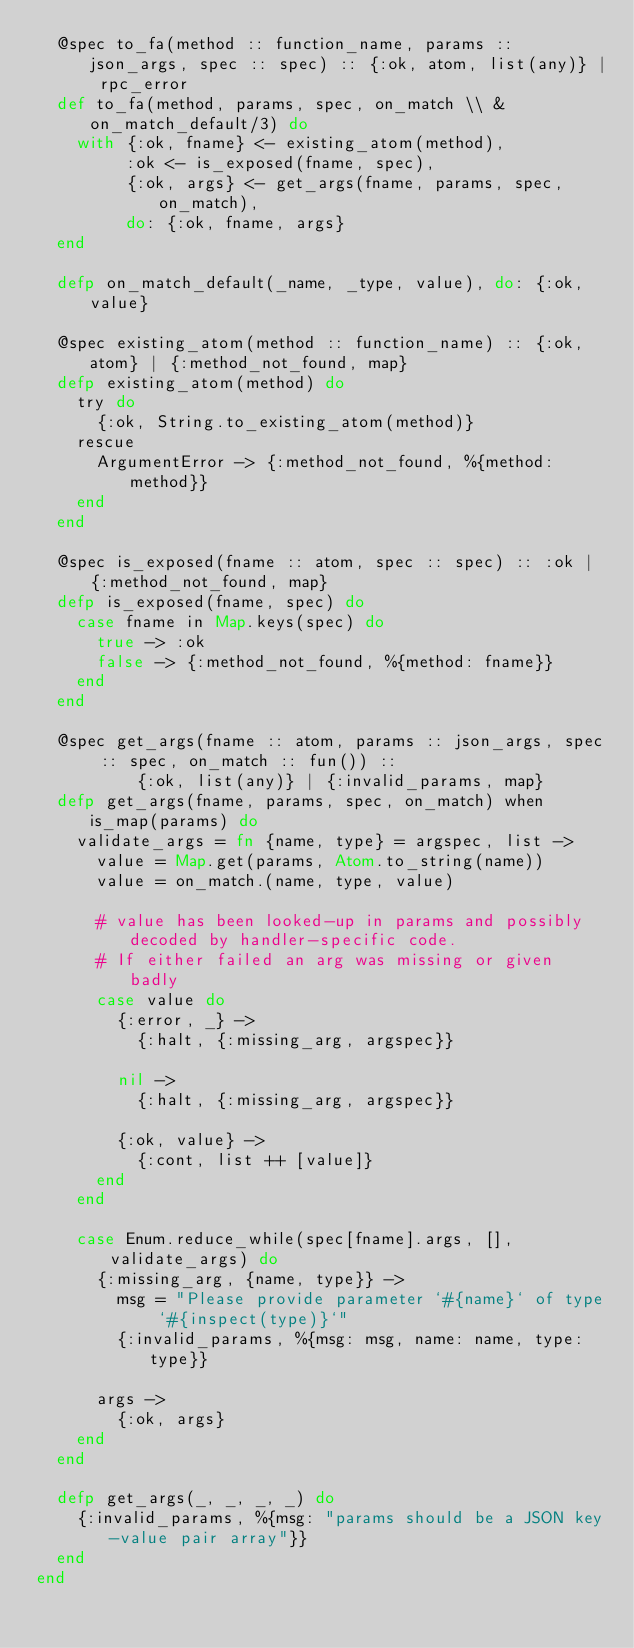<code> <loc_0><loc_0><loc_500><loc_500><_Elixir_>  @spec to_fa(method :: function_name, params :: json_args, spec :: spec) :: {:ok, atom, list(any)} | rpc_error
  def to_fa(method, params, spec, on_match \\ &on_match_default/3) do
    with {:ok, fname} <- existing_atom(method),
         :ok <- is_exposed(fname, spec),
         {:ok, args} <- get_args(fname, params, spec, on_match),
         do: {:ok, fname, args}
  end

  defp on_match_default(_name, _type, value), do: {:ok, value}

  @spec existing_atom(method :: function_name) :: {:ok, atom} | {:method_not_found, map}
  defp existing_atom(method) do
    try do
      {:ok, String.to_existing_atom(method)}
    rescue
      ArgumentError -> {:method_not_found, %{method: method}}
    end
  end

  @spec is_exposed(fname :: atom, spec :: spec) :: :ok | {:method_not_found, map}
  defp is_exposed(fname, spec) do
    case fname in Map.keys(spec) do
      true -> :ok
      false -> {:method_not_found, %{method: fname}}
    end
  end

  @spec get_args(fname :: atom, params :: json_args, spec :: spec, on_match :: fun()) ::
          {:ok, list(any)} | {:invalid_params, map}
  defp get_args(fname, params, spec, on_match) when is_map(params) do
    validate_args = fn {name, type} = argspec, list ->
      value = Map.get(params, Atom.to_string(name))
      value = on_match.(name, type, value)

      # value has been looked-up in params and possibly decoded by handler-specific code.
      # If either failed an arg was missing or given badly
      case value do
        {:error, _} ->
          {:halt, {:missing_arg, argspec}}

        nil ->
          {:halt, {:missing_arg, argspec}}

        {:ok, value} ->
          {:cont, list ++ [value]}
      end
    end

    case Enum.reduce_while(spec[fname].args, [], validate_args) do
      {:missing_arg, {name, type}} ->
        msg = "Please provide parameter `#{name}` of type `#{inspect(type)}`"
        {:invalid_params, %{msg: msg, name: name, type: type}}

      args ->
        {:ok, args}
    end
  end

  defp get_args(_, _, _, _) do
    {:invalid_params, %{msg: "params should be a JSON key-value pair array"}}
  end
end
</code> 